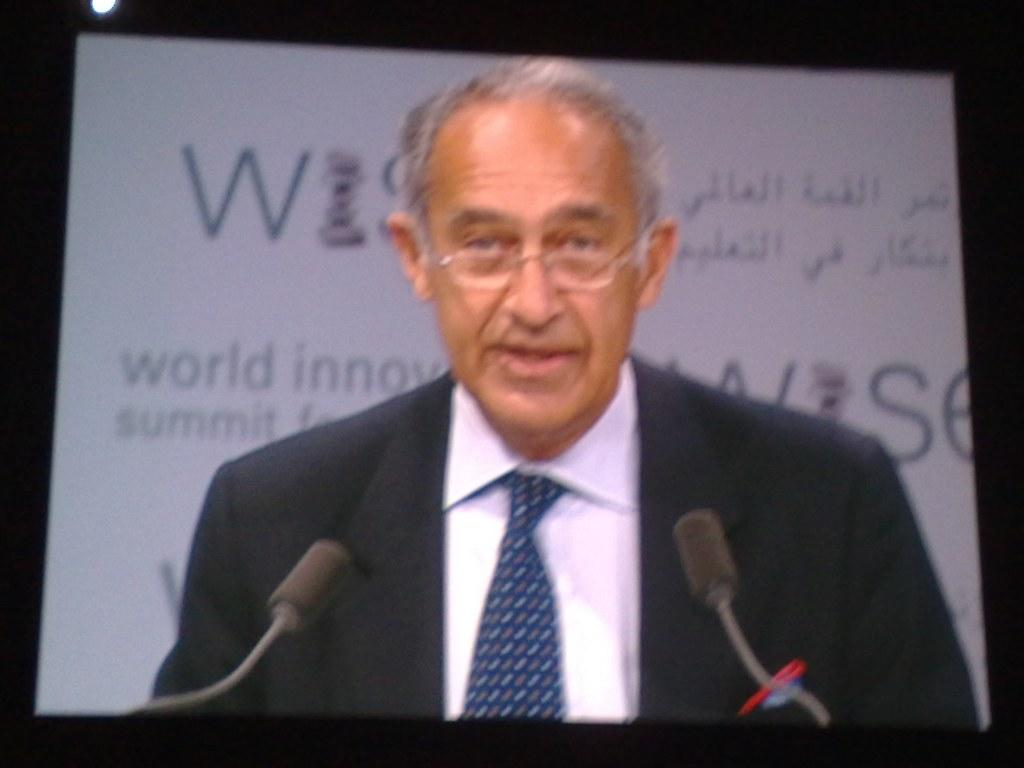What objects are located at the front of the image? There are mics in the front of the image. What can be seen in the center of the image? There is a man in the center of the image. What is present in the background of the image? There is a board with writing in the background of the image. What type of store can be seen in the background of the image? There is no store present in the image; it features a board with writing in the background. What color are the eyes of the man in the center of the image? The provided facts do not mention the color of the man's eyes, so it cannot be determined from the image. 